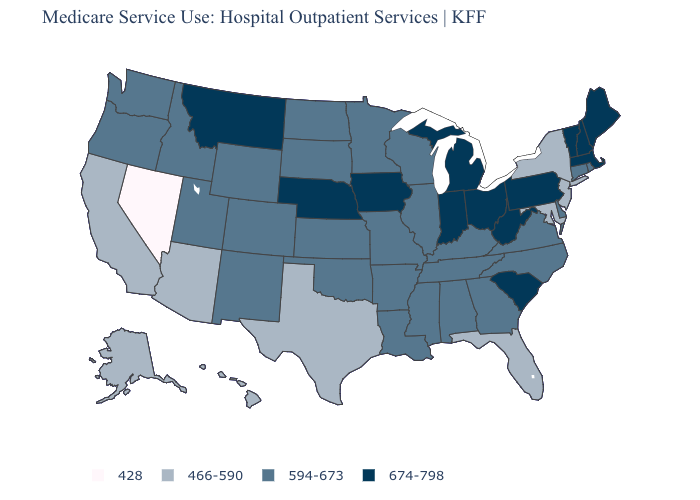Name the states that have a value in the range 594-673?
Be succinct. Alabama, Arkansas, Colorado, Connecticut, Delaware, Georgia, Idaho, Illinois, Kansas, Kentucky, Louisiana, Minnesota, Mississippi, Missouri, New Mexico, North Carolina, North Dakota, Oklahoma, Oregon, Rhode Island, South Dakota, Tennessee, Utah, Virginia, Washington, Wisconsin, Wyoming. Does the map have missing data?
Concise answer only. No. Does Mississippi have the highest value in the USA?
Concise answer only. No. Which states hav the highest value in the Northeast?
Give a very brief answer. Maine, Massachusetts, New Hampshire, Pennsylvania, Vermont. Does Massachusetts have the highest value in the USA?
Answer briefly. Yes. What is the value of New Hampshire?
Keep it brief. 674-798. Does the first symbol in the legend represent the smallest category?
Concise answer only. Yes. What is the value of Nebraska?
Concise answer only. 674-798. Does Connecticut have the lowest value in the USA?
Quick response, please. No. Which states have the highest value in the USA?
Answer briefly. Indiana, Iowa, Maine, Massachusetts, Michigan, Montana, Nebraska, New Hampshire, Ohio, Pennsylvania, South Carolina, Vermont, West Virginia. Among the states that border Massachusetts , which have the lowest value?
Quick response, please. New York. Among the states that border Rhode Island , which have the lowest value?
Write a very short answer. Connecticut. What is the highest value in the USA?
Concise answer only. 674-798. What is the value of Louisiana?
Concise answer only. 594-673. 